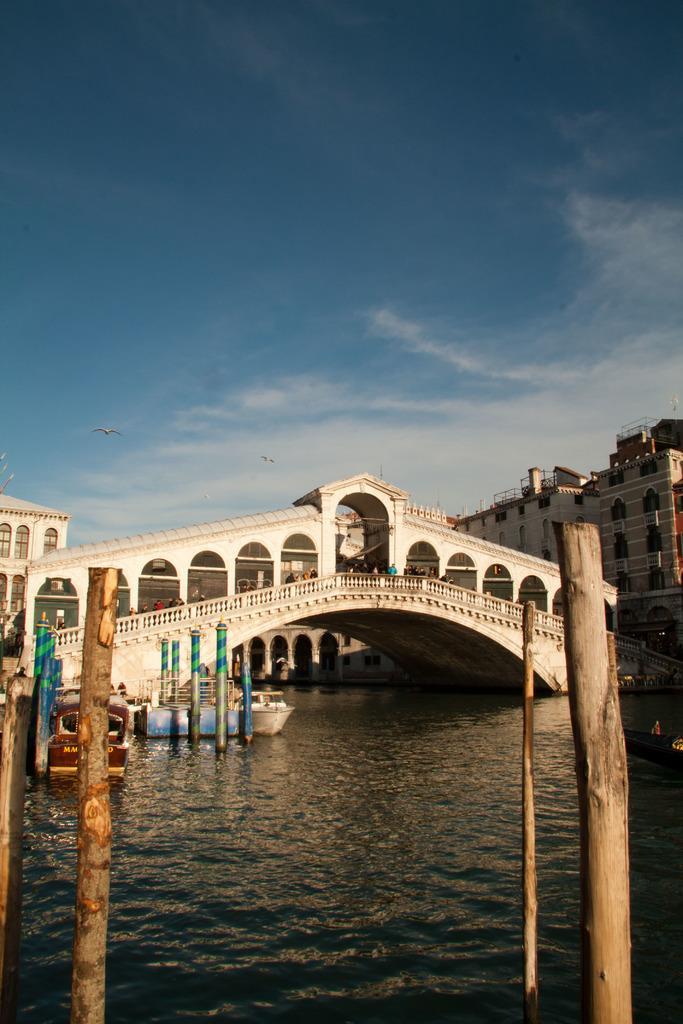Describe this image in one or two sentences. Here in this picture in the front we can see water present over a place and we can see boats present in the water and in the middle we can see bridge in an arch shaped present and we can also see shed covered through the bridge and behind that we can see buildings present in the far and we can see clouds in the sky and in the front we can see wooden poles present and we can see a bird flying in the air. 